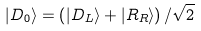<formula> <loc_0><loc_0><loc_500><loc_500>| D _ { 0 } \rangle = \left ( | D _ { L } \rangle + | R _ { R } \rangle \right ) / \sqrt { 2 }</formula> 